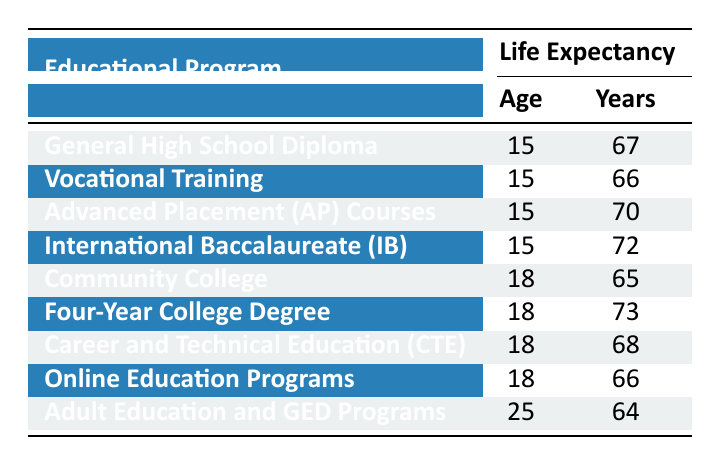What is the life expectancy for students in the International Baccalaureate program at age 15? The table lists the life expectancy for students in various educational programs. For the International Baccalaureate program, the life expectancy at age 15 is 72 years.
Answer: 72 Which educational program has the highest life expectancy at age 15? To determine which educational program has the highest life expectancy at age 15, we compare the life expectancies from the rows for programs available at that age. The International Baccalaureate has the highest value at 72 years.
Answer: International Baccalaureate (IB) What is the life expectancy for students who complete a Four-Year College Degree at age 18? The table specifies that students who complete a Four-Year College Degree have a life expectancy of 73 years at age 18.
Answer: 73 Is the life expectancy for students in Community College greater than that of those in Online Education Programs? The life expectancy for students in Community College is 65 years, while for Online Education Programs it is 66 years. Since 65 is not greater than 66, the answer is no.
Answer: No What is the average life expectancy of students across all educational programs listed at age 15? First, we identify the life expectancies at age 15: 67 (General High School), 66 (Vocational Training), 70 (AP Courses), and 72 (IB). Adding these gives 67 + 66 + 70 + 72 = 275. There are 4 programs, so the average is 275/4 = 68.75 years.
Answer: 68.75 How much longer can students expect to live who pursue a Four-Year College Degree compared to those in Adult Education and GED Programs? For a Four-Year College Degree, the life expectancy is 73 years, while for Adult Education and GED Programs, it is 64 years. The difference is 73 - 64 = 9 years.
Answer: 9 years Are students in Advanced Placement Courses expected to live longer than those in Career and Technical Education? The life expectancy for Advanced Placement Courses is 70 years and for Career and Technical Education it is 68 years. Since 70 is greater than 68, the answer is yes.
Answer: Yes What is the total life expectancy of all students at age 18 based on the educational programs listed? For age 18, the life expectancies are: 65 (Community College), 73 (Four-Year Degree), 68 (CTE), and 66 (Online Education). Adding these gives 65 + 73 + 68 + 66 = 272 years.
Answer: 272 